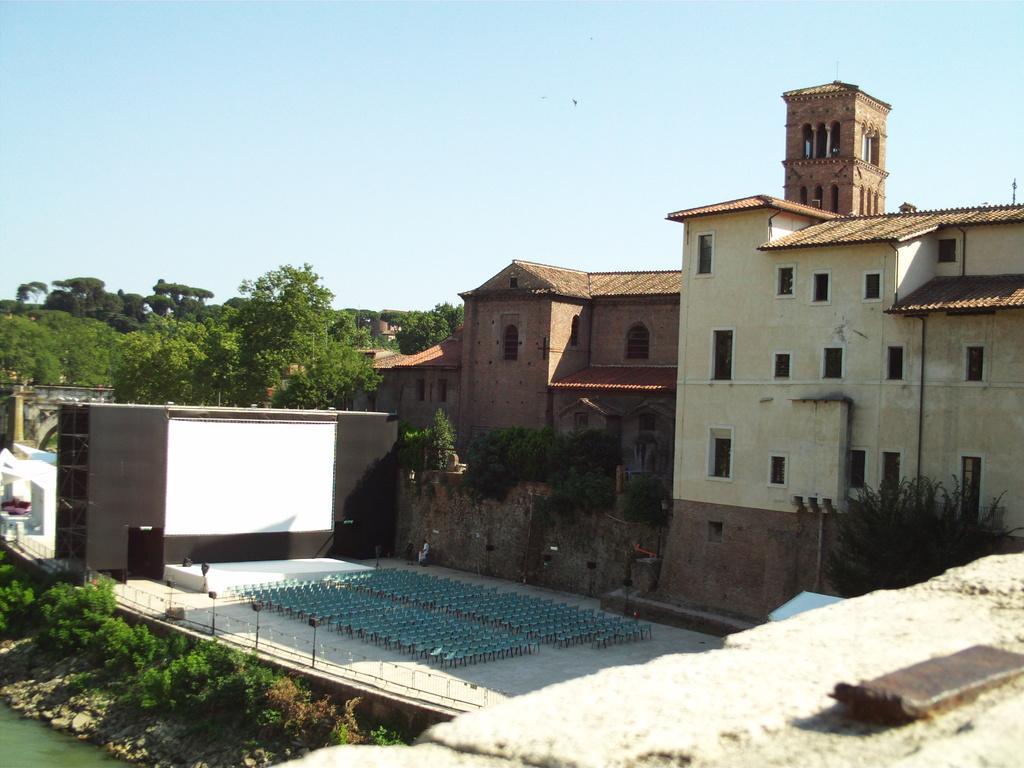Describe this image in one or two sentences. In this picture we can see the water in the bottom left. We can see plants, trees, buildings and other objects. There is the sky visible on top. 